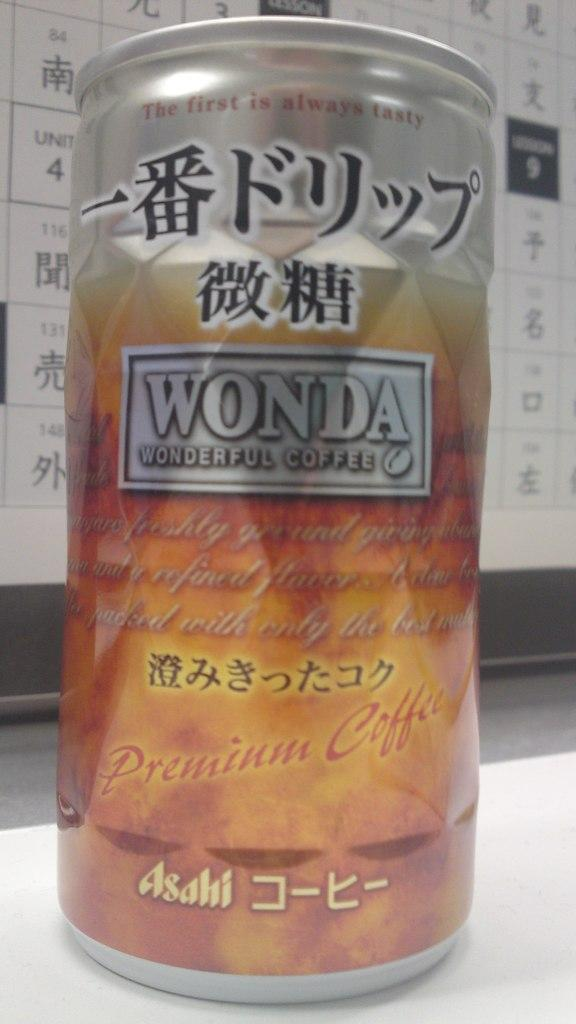<image>
Share a concise interpretation of the image provided. a can of wonda coffe with text written in japanese and english. 